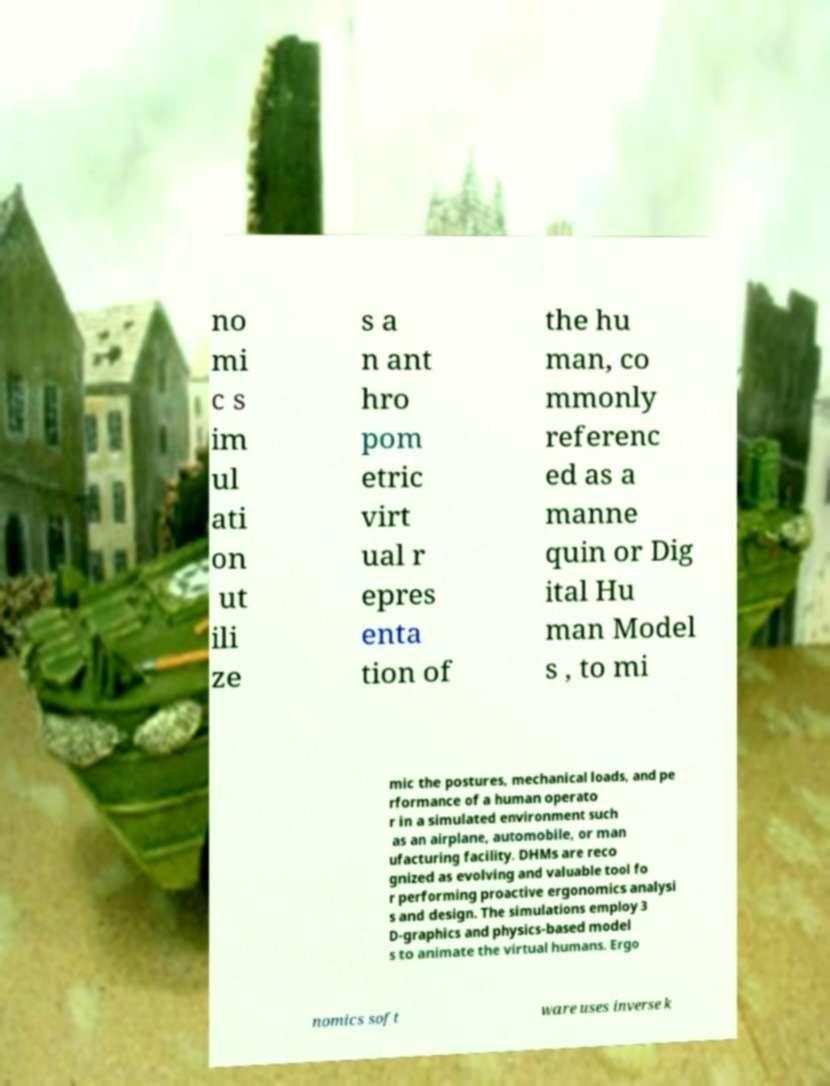I need the written content from this picture converted into text. Can you do that? no mi c s im ul ati on ut ili ze s a n ant hro pom etric virt ual r epres enta tion of the hu man, co mmonly referenc ed as a manne quin or Dig ital Hu man Model s , to mi mic the postures, mechanical loads, and pe rformance of a human operato r in a simulated environment such as an airplane, automobile, or man ufacturing facility. DHMs are reco gnized as evolving and valuable tool fo r performing proactive ergonomics analysi s and design. The simulations employ 3 D-graphics and physics-based model s to animate the virtual humans. Ergo nomics soft ware uses inverse k 